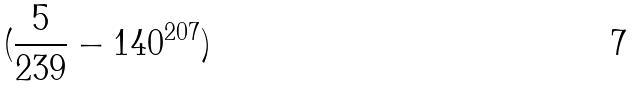Convert formula to latex. <formula><loc_0><loc_0><loc_500><loc_500>( \frac { 5 } { 2 3 9 } - 1 4 0 ^ { 2 0 7 } )</formula> 